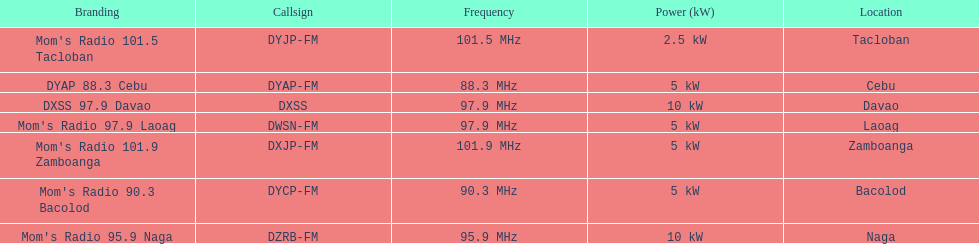Parse the table in full. {'header': ['Branding', 'Callsign', 'Frequency', 'Power (kW)', 'Location'], 'rows': [["Mom's Radio 101.5 Tacloban", 'DYJP-FM', '101.5\xa0MHz', '2.5\xa0kW', 'Tacloban'], ['DYAP 88.3 Cebu', 'DYAP-FM', '88.3\xa0MHz', '5\xa0kW', 'Cebu'], ['DXSS 97.9 Davao', 'DXSS', '97.9\xa0MHz', '10\xa0kW', 'Davao'], ["Mom's Radio 97.9 Laoag", 'DWSN-FM', '97.9\xa0MHz', '5\xa0kW', 'Laoag'], ["Mom's Radio 101.9 Zamboanga", 'DXJP-FM', '101.9\xa0MHz', '5\xa0kW', 'Zamboanga'], ["Mom's Radio 90.3 Bacolod", 'DYCP-FM', '90.3\xa0MHz', '5\xa0kW', 'Bacolod'], ["Mom's Radio 95.9 Naga", 'DZRB-FM', '95.9\xa0MHz', '10\xa0kW', 'Naga']]} What is the last location on this chart? Davao. 